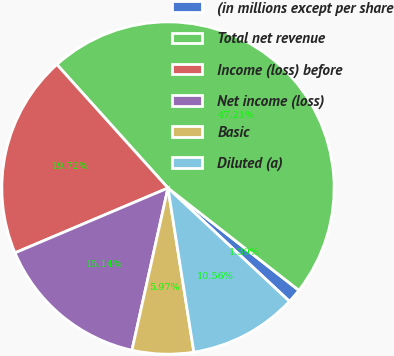Convert chart. <chart><loc_0><loc_0><loc_500><loc_500><pie_chart><fcel>(in millions except per share<fcel>Total net revenue<fcel>Income (loss) before<fcel>Net income (loss)<fcel>Basic<fcel>Diluted (a)<nl><fcel>1.39%<fcel>47.21%<fcel>19.72%<fcel>15.14%<fcel>5.97%<fcel>10.56%<nl></chart> 